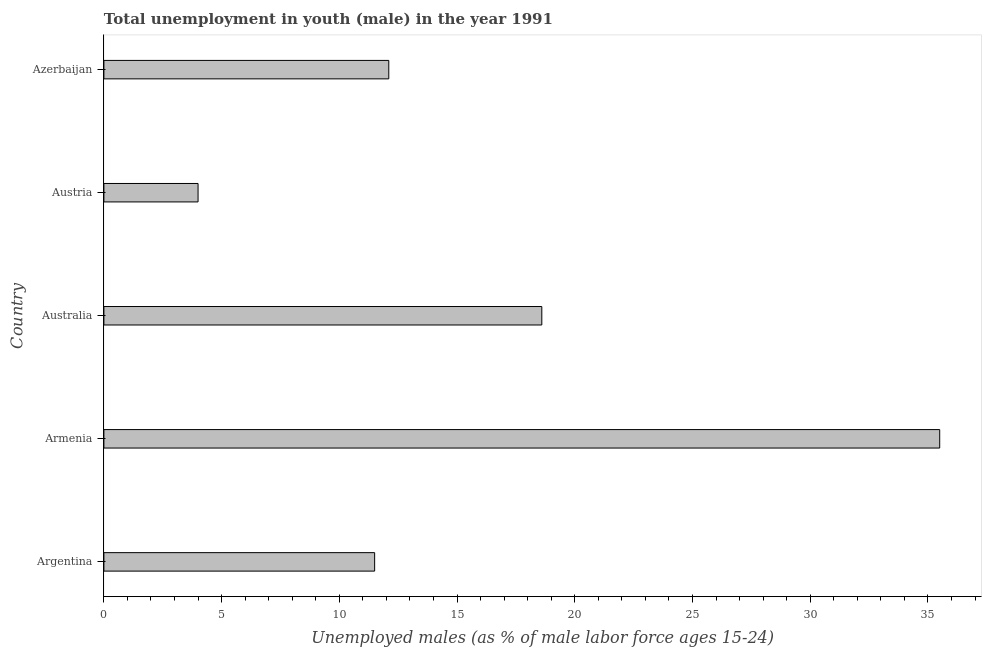Does the graph contain any zero values?
Give a very brief answer. No. What is the title of the graph?
Provide a short and direct response. Total unemployment in youth (male) in the year 1991. What is the label or title of the X-axis?
Your response must be concise. Unemployed males (as % of male labor force ages 15-24). What is the label or title of the Y-axis?
Provide a succinct answer. Country. What is the unemployed male youth population in Argentina?
Offer a very short reply. 11.5. Across all countries, what is the maximum unemployed male youth population?
Provide a short and direct response. 35.5. Across all countries, what is the minimum unemployed male youth population?
Provide a short and direct response. 4. In which country was the unemployed male youth population maximum?
Provide a short and direct response. Armenia. What is the sum of the unemployed male youth population?
Your answer should be compact. 81.7. What is the difference between the unemployed male youth population in Armenia and Austria?
Keep it short and to the point. 31.5. What is the average unemployed male youth population per country?
Provide a succinct answer. 16.34. What is the median unemployed male youth population?
Keep it short and to the point. 12.1. In how many countries, is the unemployed male youth population greater than 20 %?
Your answer should be compact. 1. What is the ratio of the unemployed male youth population in Armenia to that in Azerbaijan?
Your answer should be very brief. 2.93. What is the difference between the highest and the second highest unemployed male youth population?
Keep it short and to the point. 16.9. What is the difference between the highest and the lowest unemployed male youth population?
Your response must be concise. 31.5. In how many countries, is the unemployed male youth population greater than the average unemployed male youth population taken over all countries?
Your answer should be very brief. 2. Are the values on the major ticks of X-axis written in scientific E-notation?
Offer a terse response. No. What is the Unemployed males (as % of male labor force ages 15-24) of Armenia?
Your response must be concise. 35.5. What is the Unemployed males (as % of male labor force ages 15-24) of Australia?
Offer a terse response. 18.6. What is the Unemployed males (as % of male labor force ages 15-24) in Austria?
Ensure brevity in your answer.  4. What is the Unemployed males (as % of male labor force ages 15-24) in Azerbaijan?
Your response must be concise. 12.1. What is the difference between the Unemployed males (as % of male labor force ages 15-24) in Argentina and Armenia?
Provide a succinct answer. -24. What is the difference between the Unemployed males (as % of male labor force ages 15-24) in Argentina and Austria?
Ensure brevity in your answer.  7.5. What is the difference between the Unemployed males (as % of male labor force ages 15-24) in Argentina and Azerbaijan?
Offer a very short reply. -0.6. What is the difference between the Unemployed males (as % of male labor force ages 15-24) in Armenia and Austria?
Give a very brief answer. 31.5. What is the difference between the Unemployed males (as % of male labor force ages 15-24) in Armenia and Azerbaijan?
Provide a short and direct response. 23.4. What is the difference between the Unemployed males (as % of male labor force ages 15-24) in Australia and Austria?
Your answer should be very brief. 14.6. What is the difference between the Unemployed males (as % of male labor force ages 15-24) in Australia and Azerbaijan?
Your response must be concise. 6.5. What is the ratio of the Unemployed males (as % of male labor force ages 15-24) in Argentina to that in Armenia?
Your answer should be compact. 0.32. What is the ratio of the Unemployed males (as % of male labor force ages 15-24) in Argentina to that in Australia?
Offer a terse response. 0.62. What is the ratio of the Unemployed males (as % of male labor force ages 15-24) in Argentina to that in Austria?
Offer a very short reply. 2.88. What is the ratio of the Unemployed males (as % of male labor force ages 15-24) in Armenia to that in Australia?
Your answer should be very brief. 1.91. What is the ratio of the Unemployed males (as % of male labor force ages 15-24) in Armenia to that in Austria?
Your response must be concise. 8.88. What is the ratio of the Unemployed males (as % of male labor force ages 15-24) in Armenia to that in Azerbaijan?
Offer a very short reply. 2.93. What is the ratio of the Unemployed males (as % of male labor force ages 15-24) in Australia to that in Austria?
Your answer should be very brief. 4.65. What is the ratio of the Unemployed males (as % of male labor force ages 15-24) in Australia to that in Azerbaijan?
Give a very brief answer. 1.54. What is the ratio of the Unemployed males (as % of male labor force ages 15-24) in Austria to that in Azerbaijan?
Provide a short and direct response. 0.33. 